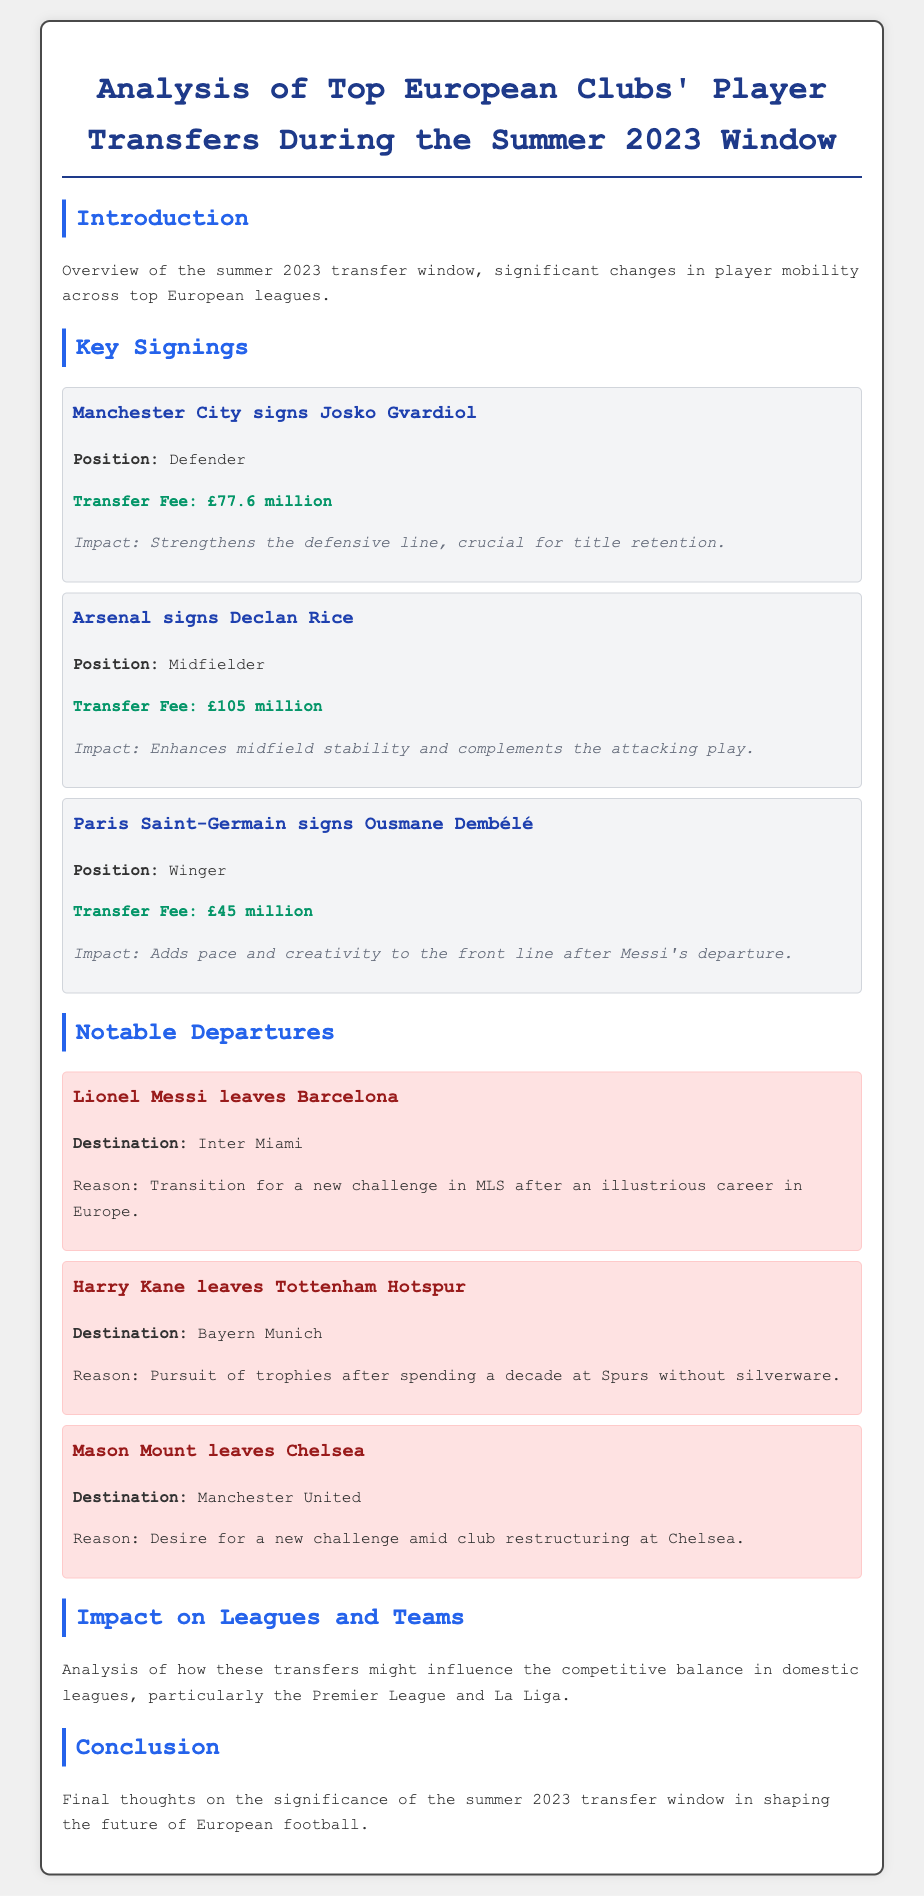What was the total transfer fee for Declan Rice? The document states that Declan Rice was signed for a transfer fee of £105 million.
Answer: £105 million Which player did Paris Saint-Germain sign? The document mentions that Ousmane Dembélé was signed by Paris Saint-Germain.
Answer: Ousmane Dembélé How much did Manchester City pay for Josko Gvardiol? The transfer fee for Josko Gvardiol is noted as £77.6 million in the document.
Answer: £77.6 million What is the reason for Lionel Messi's departure from Barcelona? The document states that Messi left for a new challenge in MLS after his career in Europe.
Answer: New challenge in MLS Which club did Mason Mount join after leaving Chelsea? The document indicates that Mason Mount joined Manchester United after leaving Chelsea.
Answer: Manchester United What impact does the transfer of Declan Rice have on Arsenal's midfield? The document notes that Declan Rice enhances midfield stability and complements attacking play.
Answer: Enhances midfield stability Which club was Harry Kane with before transferring to Bayern Munich? The document specifies that Harry Kane was with Tottenham Hotspur before his transfer.
Answer: Tottenham Hotspur What is the main focus of the analysis in the document? The document focuses on the analysis of player transfers during the summer 2023 window.
Answer: Player transfers during summer 2023 What type of document is this? The document is a detailed analysis of player transfers for European football clubs.
Answer: Analysis of player transfers 